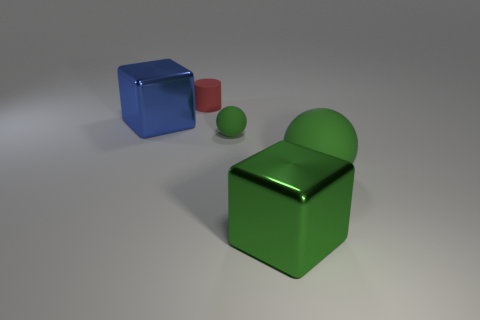How many objects are small matte cylinders behind the small rubber sphere or small red spheres?
Keep it short and to the point. 1. There is another rubber ball that is the same color as the large matte ball; what is its size?
Offer a terse response. Small. There is a big object that is on the right side of the big green cube; is its color the same as the matte ball that is on the left side of the green shiny cube?
Offer a very short reply. Yes. What is the size of the green metal object?
Keep it short and to the point. Large. What number of large things are matte balls or green things?
Provide a short and direct response. 2. The metallic object that is the same size as the blue cube is what color?
Provide a succinct answer. Green. What number of other things are there of the same shape as the tiny red rubber object?
Your response must be concise. 0. Is there a big green thing made of the same material as the big blue thing?
Provide a succinct answer. Yes. Is the cylinder left of the big green matte object made of the same material as the tiny object that is in front of the red rubber object?
Offer a terse response. Yes. What number of matte balls are there?
Provide a short and direct response. 2. 